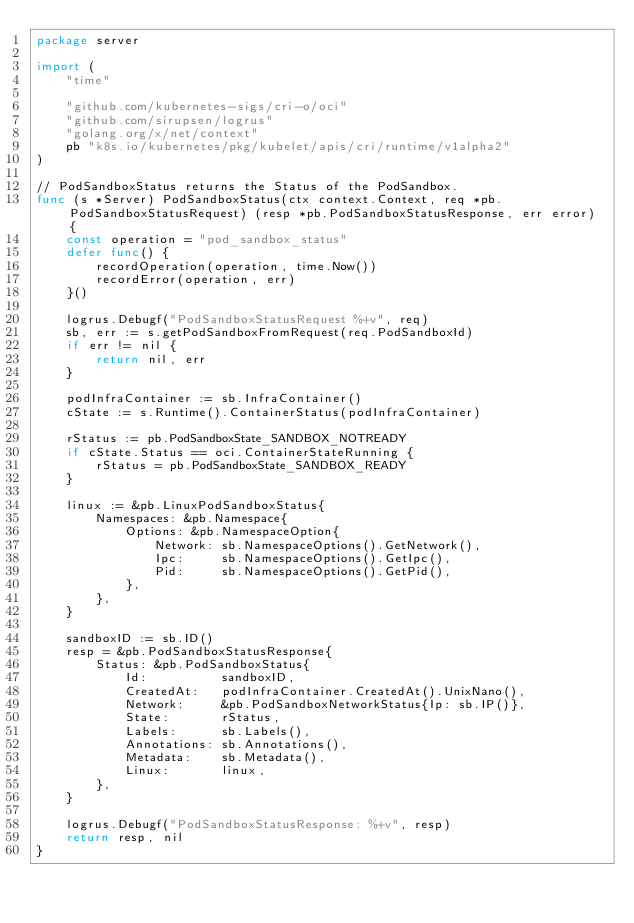<code> <loc_0><loc_0><loc_500><loc_500><_Go_>package server

import (
	"time"

	"github.com/kubernetes-sigs/cri-o/oci"
	"github.com/sirupsen/logrus"
	"golang.org/x/net/context"
	pb "k8s.io/kubernetes/pkg/kubelet/apis/cri/runtime/v1alpha2"
)

// PodSandboxStatus returns the Status of the PodSandbox.
func (s *Server) PodSandboxStatus(ctx context.Context, req *pb.PodSandboxStatusRequest) (resp *pb.PodSandboxStatusResponse, err error) {
	const operation = "pod_sandbox_status"
	defer func() {
		recordOperation(operation, time.Now())
		recordError(operation, err)
	}()

	logrus.Debugf("PodSandboxStatusRequest %+v", req)
	sb, err := s.getPodSandboxFromRequest(req.PodSandboxId)
	if err != nil {
		return nil, err
	}

	podInfraContainer := sb.InfraContainer()
	cState := s.Runtime().ContainerStatus(podInfraContainer)

	rStatus := pb.PodSandboxState_SANDBOX_NOTREADY
	if cState.Status == oci.ContainerStateRunning {
		rStatus = pb.PodSandboxState_SANDBOX_READY
	}

	linux := &pb.LinuxPodSandboxStatus{
		Namespaces: &pb.Namespace{
			Options: &pb.NamespaceOption{
				Network: sb.NamespaceOptions().GetNetwork(),
				Ipc:     sb.NamespaceOptions().GetIpc(),
				Pid:     sb.NamespaceOptions().GetPid(),
			},
		},
	}

	sandboxID := sb.ID()
	resp = &pb.PodSandboxStatusResponse{
		Status: &pb.PodSandboxStatus{
			Id:          sandboxID,
			CreatedAt:   podInfraContainer.CreatedAt().UnixNano(),
			Network:     &pb.PodSandboxNetworkStatus{Ip: sb.IP()},
			State:       rStatus,
			Labels:      sb.Labels(),
			Annotations: sb.Annotations(),
			Metadata:    sb.Metadata(),
			Linux:       linux,
		},
	}

	logrus.Debugf("PodSandboxStatusResponse: %+v", resp)
	return resp, nil
}
</code> 